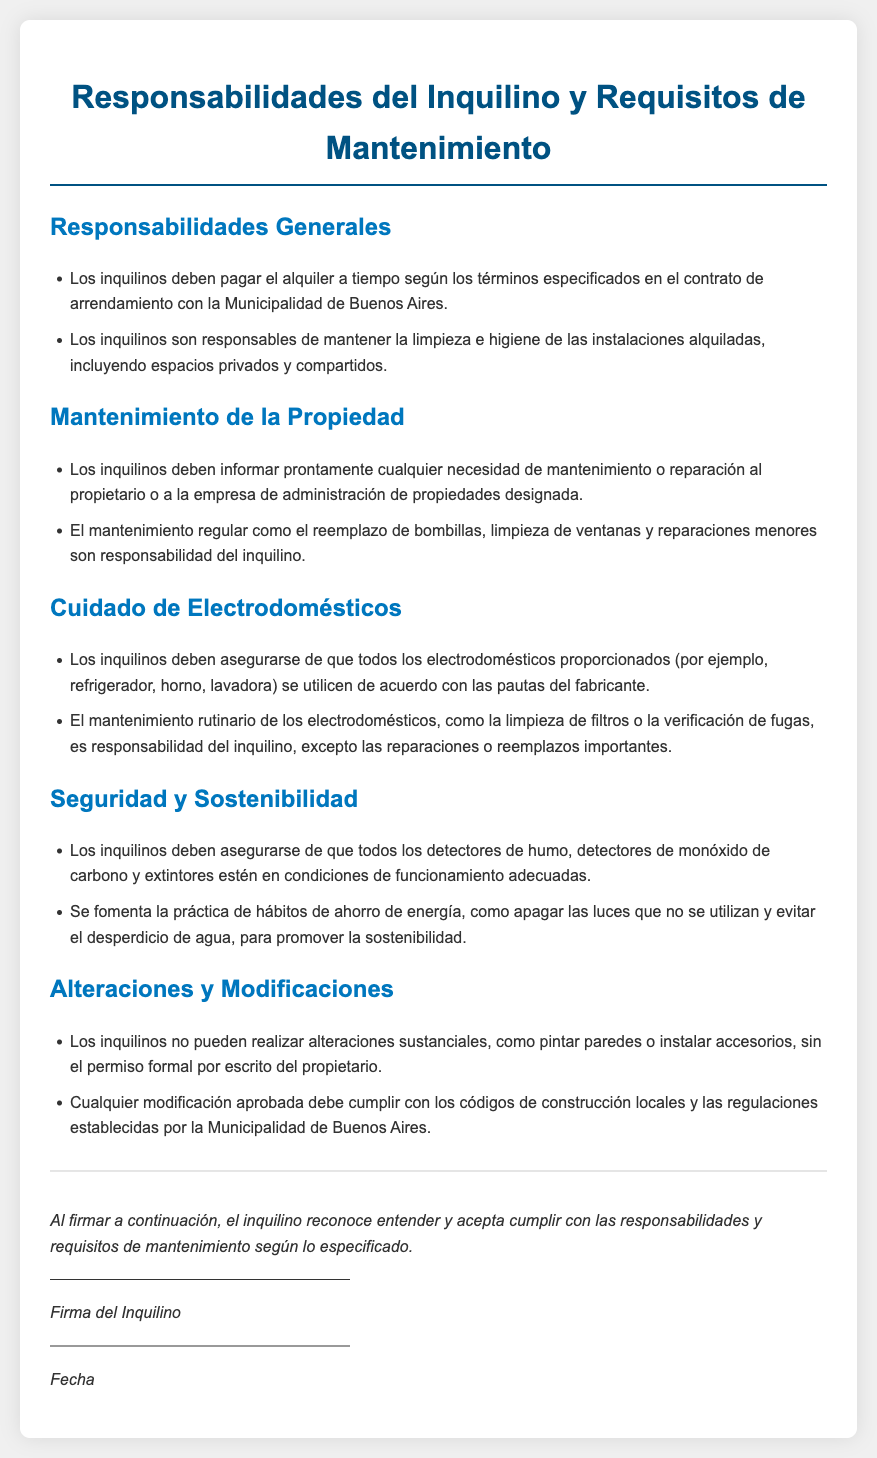what should tenants maintain in terms of cleanliness? Tenants are responsible for maintaining the cleanliness and hygiene of the rented facilities, including private and shared spaces.
Answer: limpieza e higiene what should tenants report promptly? Tenants must inform promptly any need for maintenance or repair to the owner or the designated property management company.
Answer: necesidades de mantenimiento o reparación who is responsible for regular maintenance like replacing light bulbs? Regular maintenance such as replacing light bulbs, cleaning windows, and minor repairs is the tenant's responsibility.
Answer: inquilino what type of appliances must tenants use according to manufacturer guidelines? Tenants must ensure that all provided appliances such as refrigerator, oven, and washing machine are used according to the manufacturer's guidelines.
Answer: electrodomésticos what must tenants ensure about smoke detectors? Tenants must ensure that all smoke detectors, carbon monoxide detectors, and fire extinguishers are in proper working condition.
Answer: condiciones de funcionamiento adecuadas what is required for alterations to the premises? Tenants cannot make substantial alterations without written permission from the owner, and any approved modifications must comply with local building codes.
Answer: permiso formal por escrito what is encouraged to promote sustainability? Tenants are encouraged to practice energy-saving habits like turning off unused lights and avoiding water waste.
Answer: hábitos de ahorro de energía how is the tenant's acknowledgment of responsibilities confirmed? The tenant acknowledges understanding and agrees to comply with responsibilities and maintenance requirements by signing the lease.
Answer: firma del inquilino 